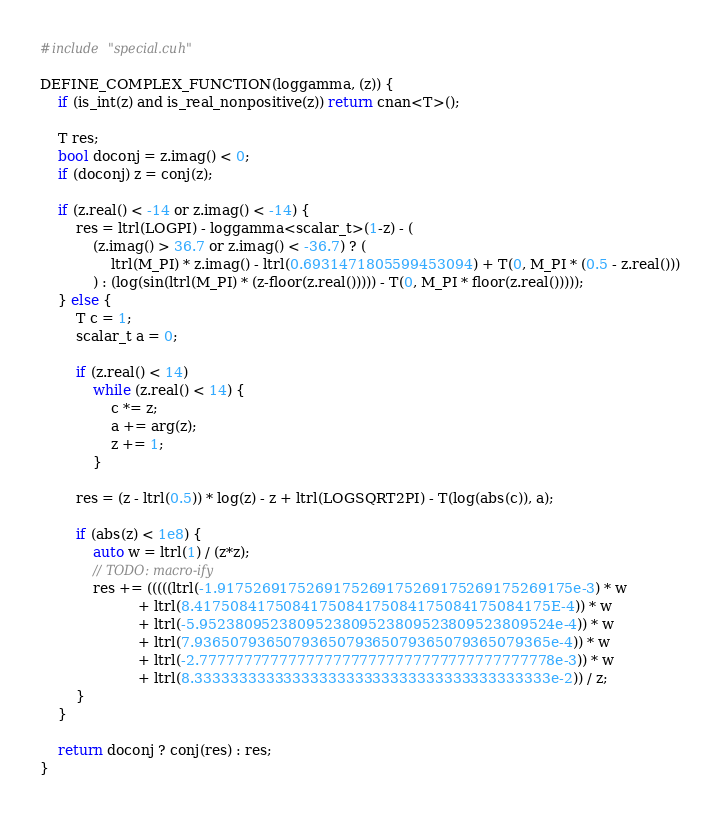<code> <loc_0><loc_0><loc_500><loc_500><_Cuda_>#include "special.cuh"

DEFINE_COMPLEX_FUNCTION(loggamma, (z)) {
    if (is_int(z) and is_real_nonpositive(z)) return cnan<T>();

    T res;
    bool doconj = z.imag() < 0;
    if (doconj) z = conj(z);

    if (z.real() < -14 or z.imag() < -14) {
        res = ltrl(LOGPI) - loggamma<scalar_t>(1-z) - (
            (z.imag() > 36.7 or z.imag() < -36.7) ? (
                ltrl(M_PI) * z.imag() - ltrl(0.6931471805599453094) + T(0, M_PI * (0.5 - z.real()))
            ) : (log(sin(ltrl(M_PI) * (z-floor(z.real())))) - T(0, M_PI * floor(z.real()))));
    } else {
        T c = 1;
        scalar_t a = 0;

        if (z.real() < 14)
            while (z.real() < 14) {
                c *= z;
                a += arg(z);
                z += 1;
            }

        res = (z - ltrl(0.5)) * log(z) - z + ltrl(LOGSQRT2PI) - T(log(abs(c)), a);

        if (abs(z) < 1e8) {
            auto w = ltrl(1) / (z*z);
            // TODO: macro-ify
            res += (((((ltrl(-1.9175269175269175269175269175269175269175e-3) * w
                      + ltrl(8.4175084175084175084175084175084175084175E-4)) * w
                      + ltrl(-5.9523809523809523809523809523809523809524e-4)) * w
                      + ltrl(7.9365079365079365079365079365079365079365e-4)) * w
                      + ltrl(-2.7777777777777777777777777777777777777778e-3)) * w
                      + ltrl(8.3333333333333333333333333333333333333333e-2)) / z;
        }
    }

    return doconj ? conj(res) : res;
}
</code> 